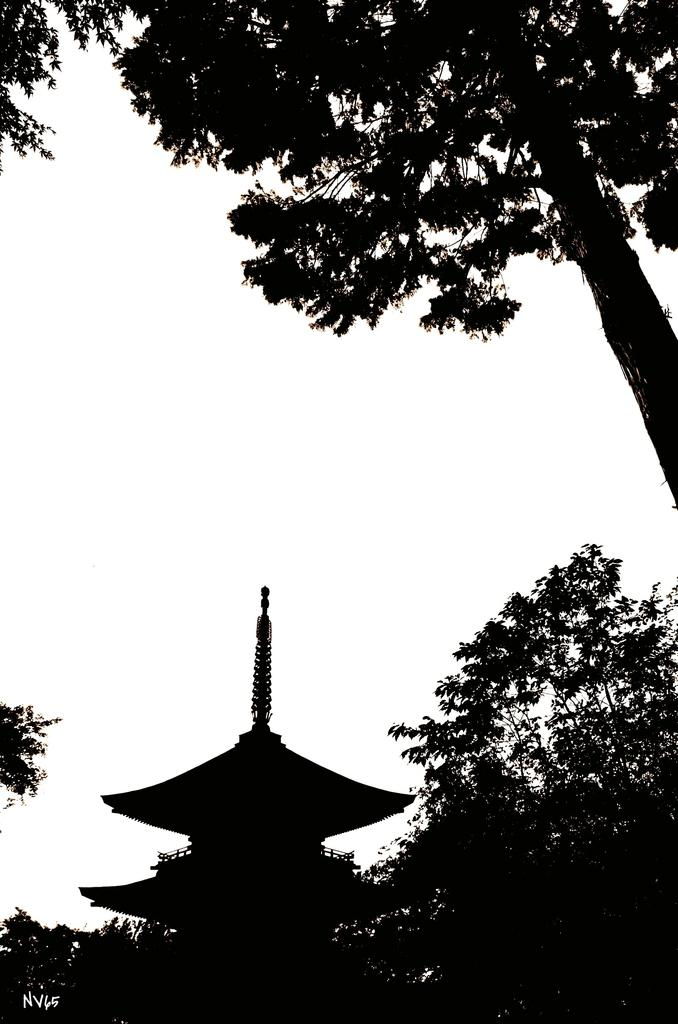What is the color scheme of the image? The image is black and white. What type of structure can be seen in the image? There is a house in the image. What other elements are present in the image besides the house? There are trees in the image. What song is being sung by the babies in the image? There are no babies or songs present in the image; it features a black and white house and trees. 